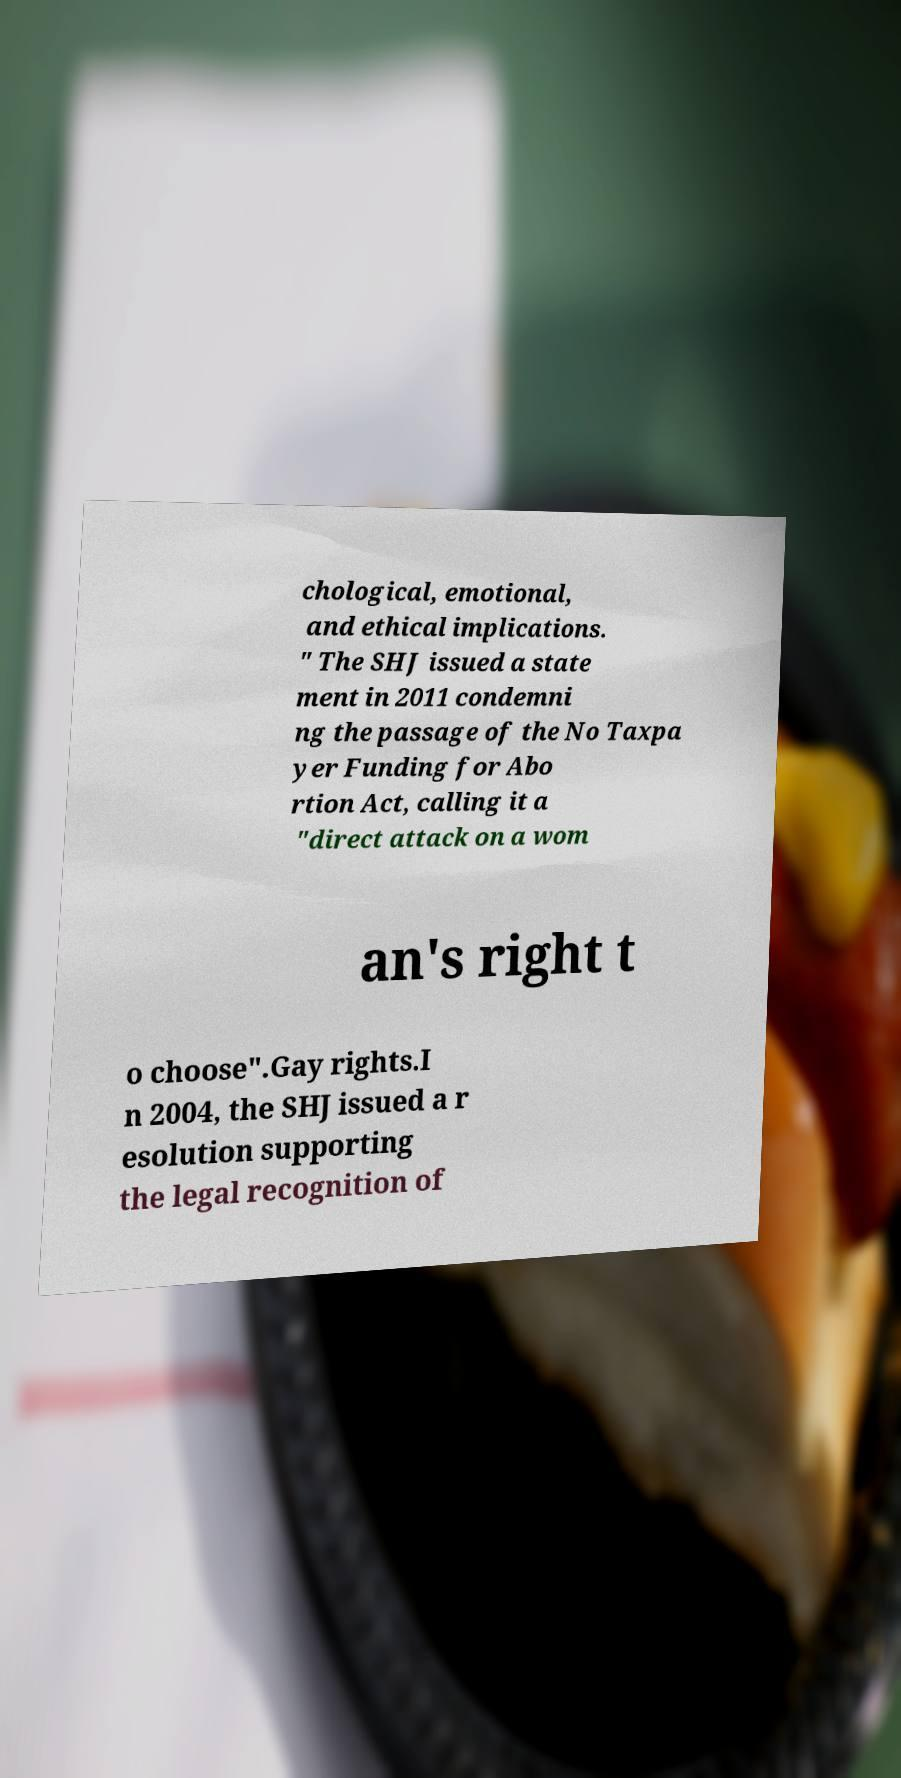Can you accurately transcribe the text from the provided image for me? chological, emotional, and ethical implications. " The SHJ issued a state ment in 2011 condemni ng the passage of the No Taxpa yer Funding for Abo rtion Act, calling it a "direct attack on a wom an's right t o choose".Gay rights.I n 2004, the SHJ issued a r esolution supporting the legal recognition of 